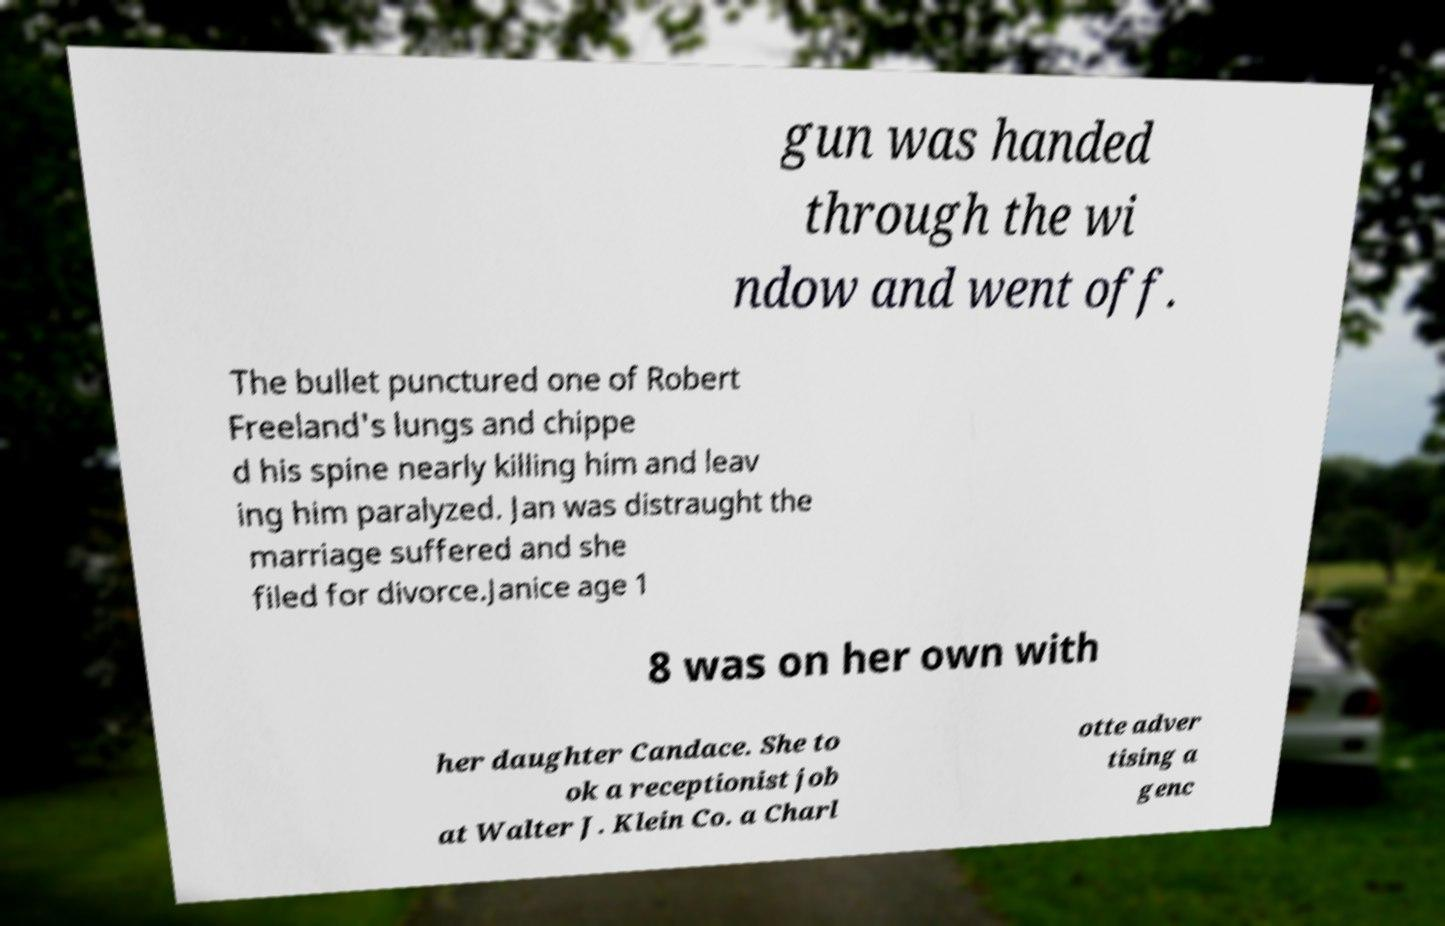Please read and relay the text visible in this image. What does it say? gun was handed through the wi ndow and went off. The bullet punctured one of Robert Freeland's lungs and chippe d his spine nearly killing him and leav ing him paralyzed. Jan was distraught the marriage suffered and she filed for divorce.Janice age 1 8 was on her own with her daughter Candace. She to ok a receptionist job at Walter J. Klein Co. a Charl otte adver tising a genc 